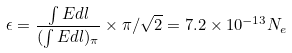Convert formula to latex. <formula><loc_0><loc_0><loc_500><loc_500>\epsilon = \frac { \int E d l } { ( \int E d l ) _ { \pi } } \times { \pi } / \sqrt { 2 } = 7 . 2 \times 1 0 ^ { - 1 3 } N _ { e }</formula> 